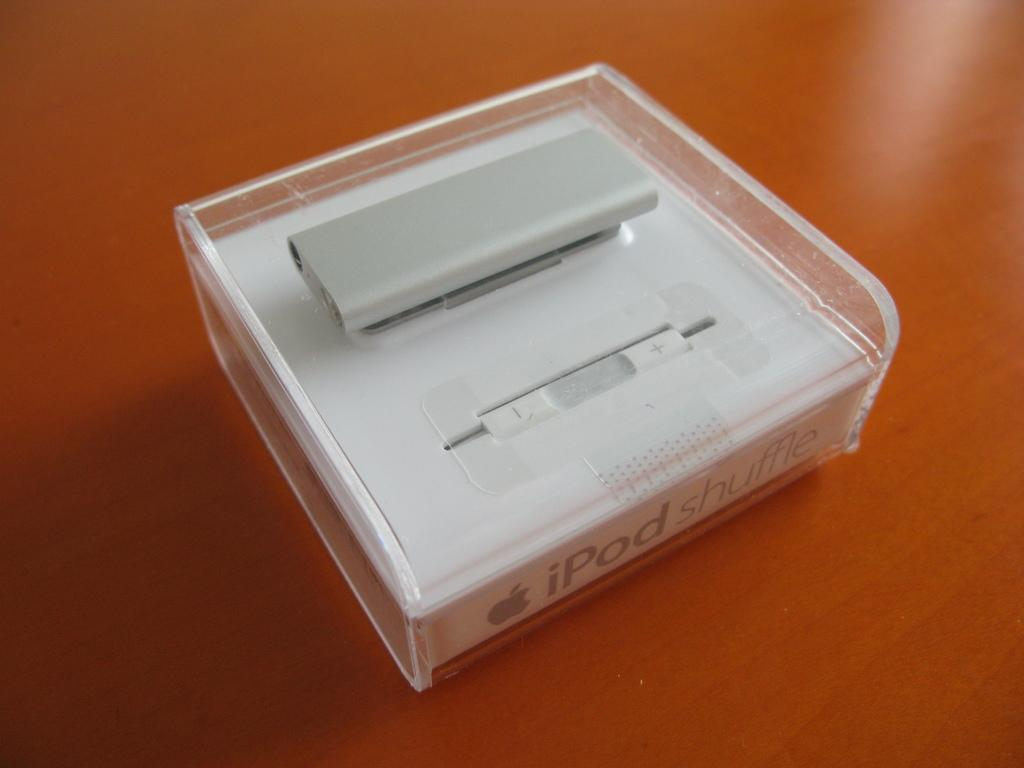Provide a one-sentence caption for the provided image. A white iPod shuffle sealed in store packaging with sensor. 